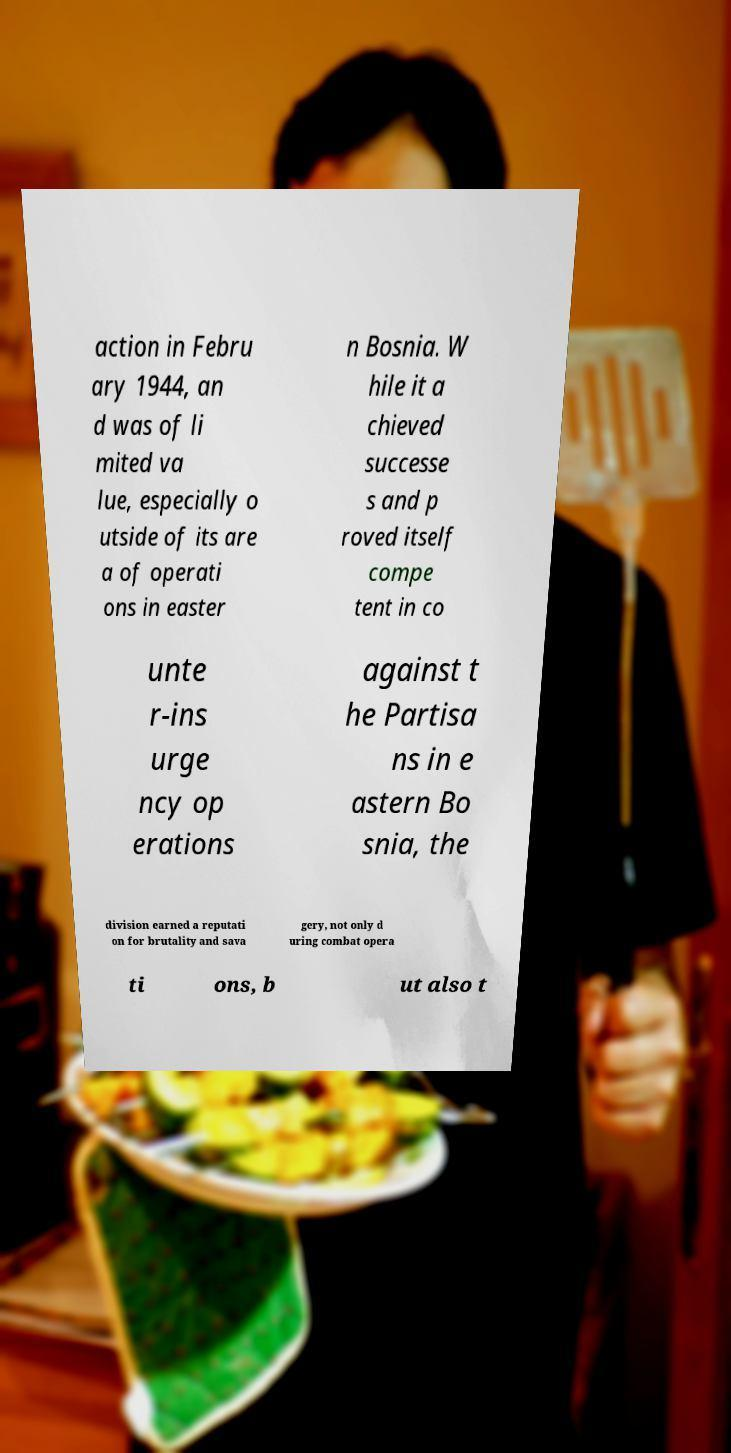For documentation purposes, I need the text within this image transcribed. Could you provide that? action in Febru ary 1944, an d was of li mited va lue, especially o utside of its are a of operati ons in easter n Bosnia. W hile it a chieved successe s and p roved itself compe tent in co unte r-ins urge ncy op erations against t he Partisa ns in e astern Bo snia, the division earned a reputati on for brutality and sava gery, not only d uring combat opera ti ons, b ut also t 